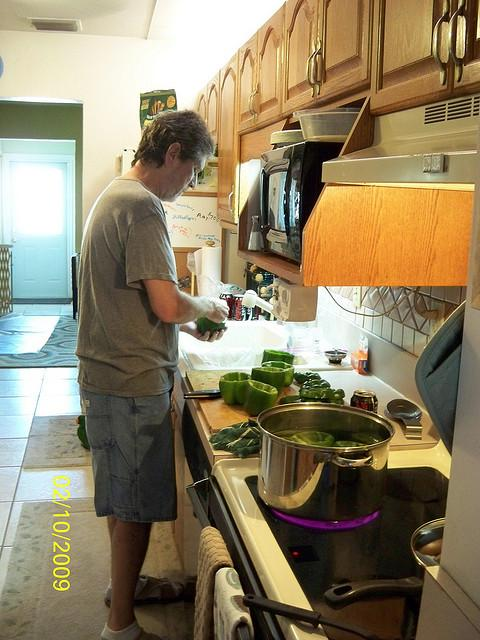What is the person cutting?

Choices:
A) paper
B) onions
C) green peppers
D) grapes green peppers 